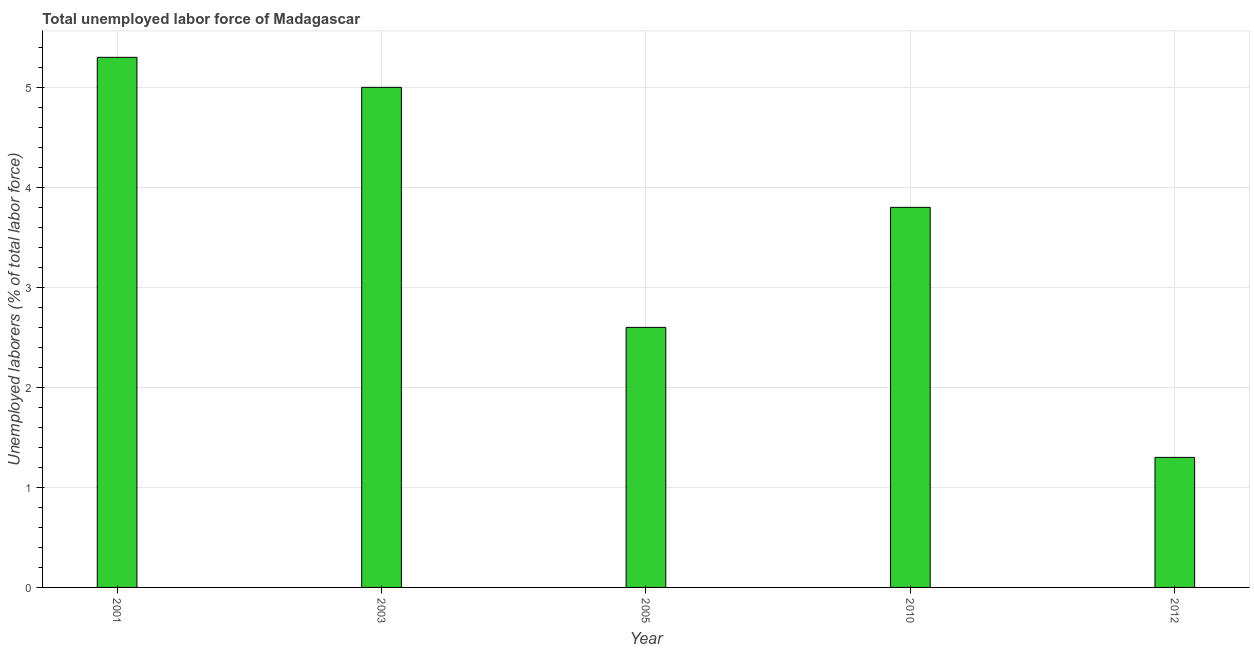Does the graph contain any zero values?
Provide a short and direct response. No. What is the title of the graph?
Keep it short and to the point. Total unemployed labor force of Madagascar. What is the label or title of the Y-axis?
Provide a short and direct response. Unemployed laborers (% of total labor force). What is the total unemployed labour force in 2005?
Ensure brevity in your answer.  2.6. Across all years, what is the maximum total unemployed labour force?
Make the answer very short. 5.3. Across all years, what is the minimum total unemployed labour force?
Your response must be concise. 1.3. In which year was the total unemployed labour force maximum?
Provide a short and direct response. 2001. In which year was the total unemployed labour force minimum?
Provide a short and direct response. 2012. What is the sum of the total unemployed labour force?
Your answer should be very brief. 18. What is the median total unemployed labour force?
Give a very brief answer. 3.8. In how many years, is the total unemployed labour force greater than 2 %?
Give a very brief answer. 4. What is the ratio of the total unemployed labour force in 2001 to that in 2010?
Provide a succinct answer. 1.4. Is the difference between the total unemployed labour force in 2001 and 2003 greater than the difference between any two years?
Your answer should be very brief. No. Is the sum of the total unemployed labour force in 2001 and 2005 greater than the maximum total unemployed labour force across all years?
Offer a terse response. Yes. In how many years, is the total unemployed labour force greater than the average total unemployed labour force taken over all years?
Your answer should be compact. 3. Are all the bars in the graph horizontal?
Provide a succinct answer. No. How many years are there in the graph?
Keep it short and to the point. 5. What is the Unemployed laborers (% of total labor force) of 2001?
Provide a succinct answer. 5.3. What is the Unemployed laborers (% of total labor force) in 2003?
Make the answer very short. 5. What is the Unemployed laborers (% of total labor force) in 2005?
Provide a succinct answer. 2.6. What is the Unemployed laborers (% of total labor force) in 2010?
Provide a short and direct response. 3.8. What is the Unemployed laborers (% of total labor force) of 2012?
Provide a short and direct response. 1.3. What is the difference between the Unemployed laborers (% of total labor force) in 2001 and 2012?
Keep it short and to the point. 4. What is the difference between the Unemployed laborers (% of total labor force) in 2003 and 2012?
Offer a very short reply. 3.7. What is the difference between the Unemployed laborers (% of total labor force) in 2005 and 2010?
Give a very brief answer. -1.2. What is the difference between the Unemployed laborers (% of total labor force) in 2005 and 2012?
Make the answer very short. 1.3. What is the ratio of the Unemployed laborers (% of total labor force) in 2001 to that in 2003?
Keep it short and to the point. 1.06. What is the ratio of the Unemployed laborers (% of total labor force) in 2001 to that in 2005?
Keep it short and to the point. 2.04. What is the ratio of the Unemployed laborers (% of total labor force) in 2001 to that in 2010?
Give a very brief answer. 1.4. What is the ratio of the Unemployed laborers (% of total labor force) in 2001 to that in 2012?
Offer a terse response. 4.08. What is the ratio of the Unemployed laborers (% of total labor force) in 2003 to that in 2005?
Offer a terse response. 1.92. What is the ratio of the Unemployed laborers (% of total labor force) in 2003 to that in 2010?
Your answer should be compact. 1.32. What is the ratio of the Unemployed laborers (% of total labor force) in 2003 to that in 2012?
Provide a succinct answer. 3.85. What is the ratio of the Unemployed laborers (% of total labor force) in 2005 to that in 2010?
Make the answer very short. 0.68. What is the ratio of the Unemployed laborers (% of total labor force) in 2010 to that in 2012?
Provide a succinct answer. 2.92. 